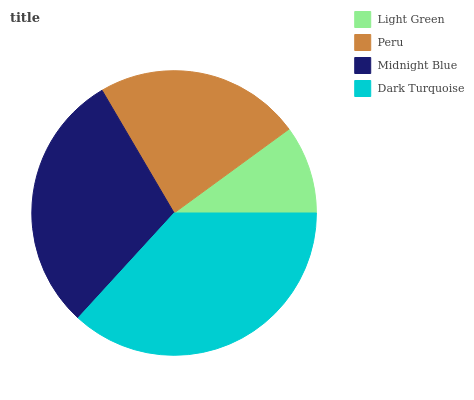Is Light Green the minimum?
Answer yes or no. Yes. Is Dark Turquoise the maximum?
Answer yes or no. Yes. Is Peru the minimum?
Answer yes or no. No. Is Peru the maximum?
Answer yes or no. No. Is Peru greater than Light Green?
Answer yes or no. Yes. Is Light Green less than Peru?
Answer yes or no. Yes. Is Light Green greater than Peru?
Answer yes or no. No. Is Peru less than Light Green?
Answer yes or no. No. Is Midnight Blue the high median?
Answer yes or no. Yes. Is Peru the low median?
Answer yes or no. Yes. Is Peru the high median?
Answer yes or no. No. Is Light Green the low median?
Answer yes or no. No. 